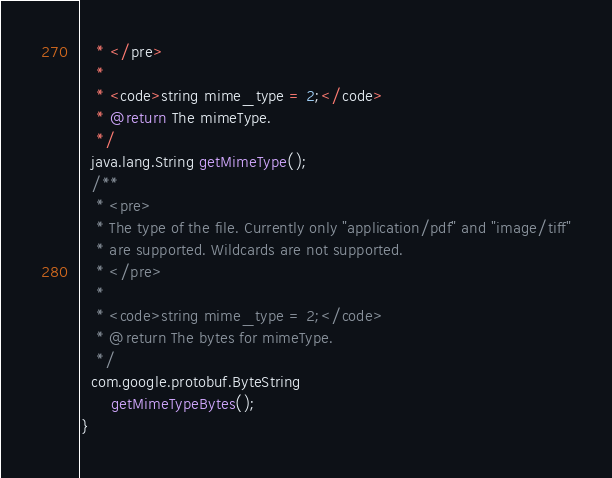Convert code to text. <code><loc_0><loc_0><loc_500><loc_500><_Java_>   * </pre>
   *
   * <code>string mime_type = 2;</code>
   * @return The mimeType.
   */
  java.lang.String getMimeType();
  /**
   * <pre>
   * The type of the file. Currently only "application/pdf" and "image/tiff"
   * are supported. Wildcards are not supported.
   * </pre>
   *
   * <code>string mime_type = 2;</code>
   * @return The bytes for mimeType.
   */
  com.google.protobuf.ByteString
      getMimeTypeBytes();
}
</code> 